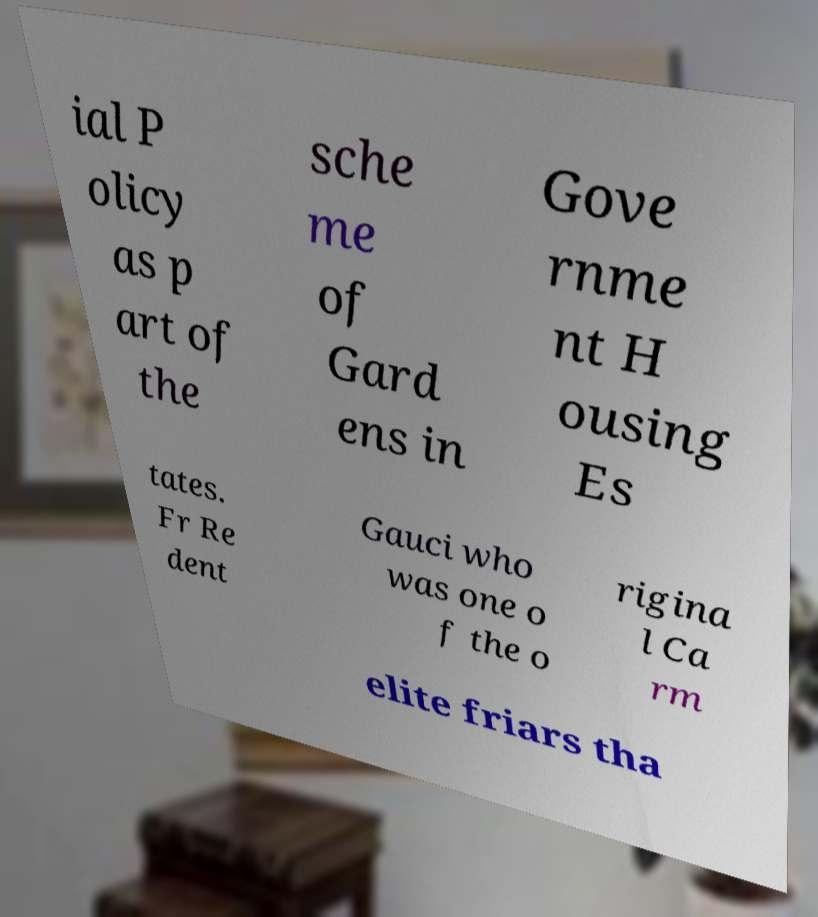Could you extract and type out the text from this image? ial P olicy as p art of the sche me of Gard ens in Gove rnme nt H ousing Es tates. Fr Re dent Gauci who was one o f the o rigina l Ca rm elite friars tha 